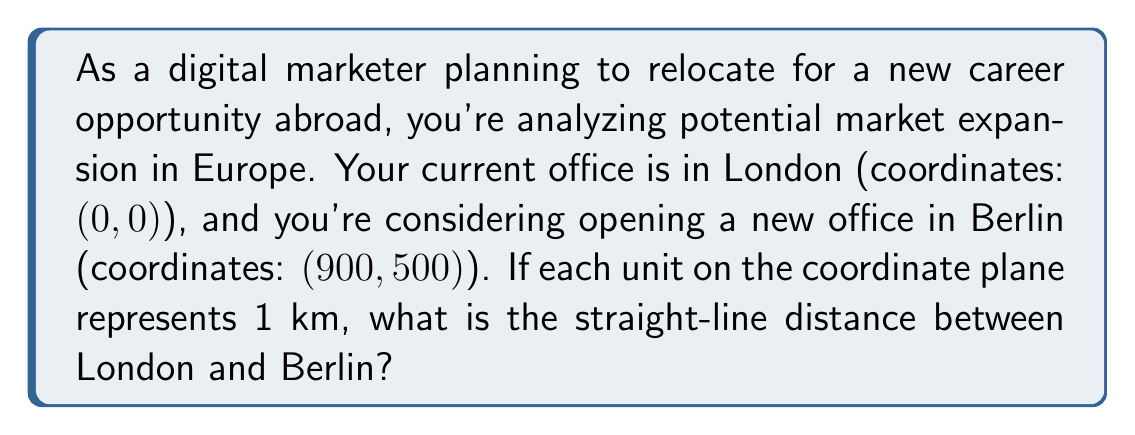Teach me how to tackle this problem. To solve this problem, we'll use the distance formula derived from the Pythagorean theorem:

$$d = \sqrt{(x_2 - x_1)^2 + (y_2 - y_1)^2}$$

Where:
$(x_1, y_1)$ is the coordinate of the first point (London)
$(x_2, y_2)$ is the coordinate of the second point (Berlin)

Step 1: Identify the coordinates
London: $(x_1, y_1) = (0, 0)$
Berlin: $(x_2, y_2) = (900, 500)$

Step 2: Plug the values into the distance formula
$$d = \sqrt{(900 - 0)^2 + (500 - 0)^2}$$

Step 3: Simplify the expressions inside the parentheses
$$d = \sqrt{900^2 + 500^2}$$

Step 4: Calculate the squares
$$d = \sqrt{810,000 + 250,000}$$

Step 5: Add the values under the square root
$$d = \sqrt{1,060,000}$$

Step 6: Calculate the square root
$$d = 1,029.56...$$

Since each unit represents 1 km, the distance is approximately 1,029.56 km.

[asy]
unitsize(0.1cm);
draw((-50,-50)--(950,550),gray);
dot((0,0));
dot((900,500));
label("London (0,0)", (0,0), SW);
label("Berlin (900,500)", (900,500), NE);
label("1,029.56 km", (450,250), SE);
[/asy]
Answer: $1,029.56$ km 